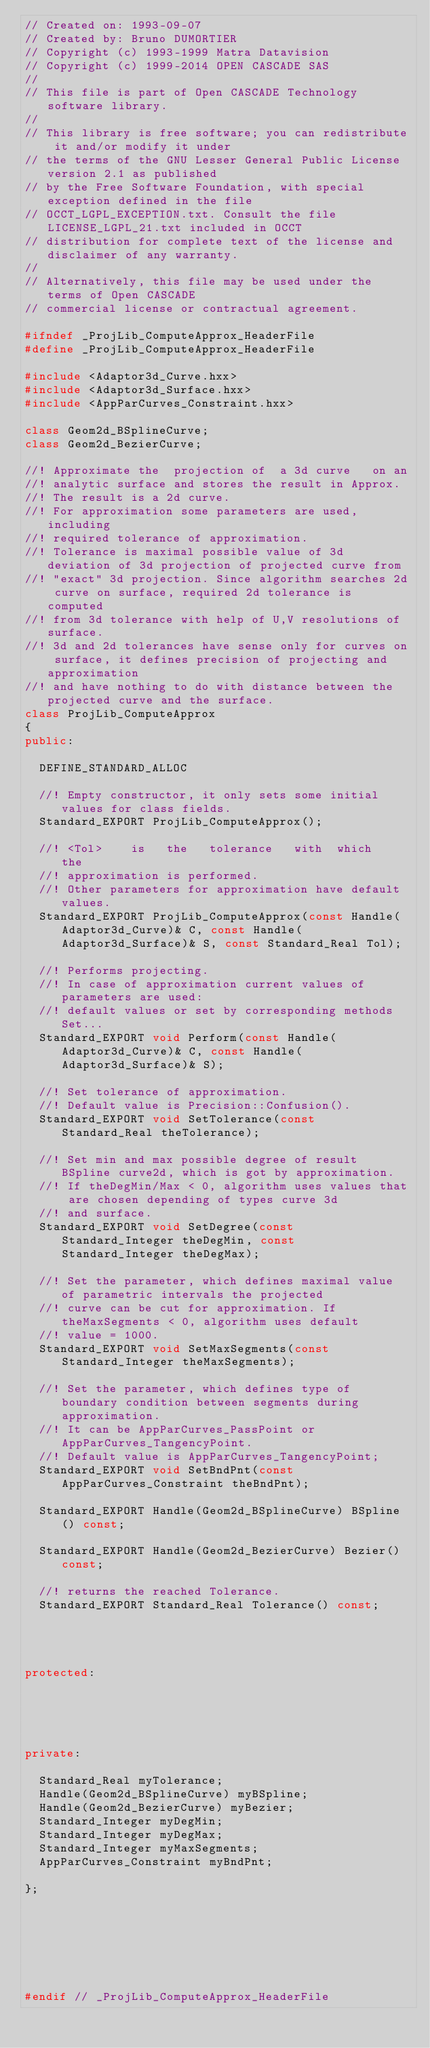<code> <loc_0><loc_0><loc_500><loc_500><_C++_>// Created on: 1993-09-07
// Created by: Bruno DUMORTIER
// Copyright (c) 1993-1999 Matra Datavision
// Copyright (c) 1999-2014 OPEN CASCADE SAS
//
// This file is part of Open CASCADE Technology software library.
//
// This library is free software; you can redistribute it and/or modify it under
// the terms of the GNU Lesser General Public License version 2.1 as published
// by the Free Software Foundation, with special exception defined in the file
// OCCT_LGPL_EXCEPTION.txt. Consult the file LICENSE_LGPL_21.txt included in OCCT
// distribution for complete text of the license and disclaimer of any warranty.
//
// Alternatively, this file may be used under the terms of Open CASCADE
// commercial license or contractual agreement.

#ifndef _ProjLib_ComputeApprox_HeaderFile
#define _ProjLib_ComputeApprox_HeaderFile

#include <Adaptor3d_Curve.hxx>
#include <Adaptor3d_Surface.hxx>
#include <AppParCurves_Constraint.hxx>

class Geom2d_BSplineCurve;
class Geom2d_BezierCurve;

//! Approximate the  projection of  a 3d curve   on an
//! analytic surface and stores the result in Approx.
//! The result is a 2d curve.
//! For approximation some parameters are used, including 
//! required tolerance of approximation.
//! Tolerance is maximal possible value of 3d deviation of 3d projection of projected curve from
//! "exact" 3d projection. Since algorithm searches 2d curve on surface, required 2d tolerance is computed
//! from 3d tolerance with help of U,V resolutions of surface.
//! 3d and 2d tolerances have sense only for curves on surface, it defines precision of projecting and approximation
//! and have nothing to do with distance between the projected curve and the surface.
class ProjLib_ComputeApprox 
{
public:

  DEFINE_STANDARD_ALLOC

  //! Empty constructor, it only sets some initial values for class fields.
  Standard_EXPORT ProjLib_ComputeApprox();
   
  //! <Tol>    is   the   tolerance   with  which    the
  //! approximation is performed.
  //! Other parameters for approximation have default values.
  Standard_EXPORT ProjLib_ComputeApprox(const Handle(Adaptor3d_Curve)& C, const Handle(Adaptor3d_Surface)& S, const Standard_Real Tol);
  
  //! Performs projecting.
  //! In case of approximation current values of parameters are used:
  //! default values or set by corresponding methods Set...
  Standard_EXPORT void Perform(const Handle(Adaptor3d_Curve)& C, const Handle(Adaptor3d_Surface)& S);

  //! Set tolerance of approximation.
  //! Default value is Precision::Confusion().
  Standard_EXPORT void SetTolerance(const Standard_Real theTolerance);

  //! Set min and max possible degree of result BSpline curve2d, which is got by approximation.
  //! If theDegMin/Max < 0, algorithm uses values that are chosen depending of types curve 3d
  //! and surface.
  Standard_EXPORT void SetDegree(const Standard_Integer theDegMin, const Standard_Integer theDegMax);

  //! Set the parameter, which defines maximal value of parametric intervals the projected
  //! curve can be cut for approximation. If theMaxSegments < 0, algorithm uses default 
  //! value = 1000.
  Standard_EXPORT void SetMaxSegments(const Standard_Integer theMaxSegments);

  //! Set the parameter, which defines type of boundary condition between segments during approximation.
  //! It can be AppParCurves_PassPoint or AppParCurves_TangencyPoint.
  //! Default value is AppParCurves_TangencyPoint;
  Standard_EXPORT void SetBndPnt(const AppParCurves_Constraint theBndPnt);

  Standard_EXPORT Handle(Geom2d_BSplineCurve) BSpline() const;
  
  Standard_EXPORT Handle(Geom2d_BezierCurve) Bezier() const;
  
  //! returns the reached Tolerance.
  Standard_EXPORT Standard_Real Tolerance() const;




protected:





private:

  Standard_Real myTolerance;
  Handle(Geom2d_BSplineCurve) myBSpline;
  Handle(Geom2d_BezierCurve) myBezier;
  Standard_Integer myDegMin;
  Standard_Integer myDegMax;
  Standard_Integer myMaxSegments;
  AppParCurves_Constraint myBndPnt;

};







#endif // _ProjLib_ComputeApprox_HeaderFile
</code> 